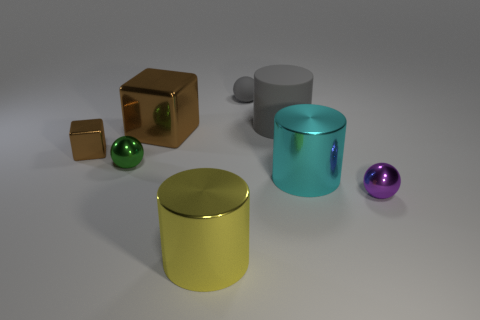What material is the tiny ball that is on the right side of the matte thing that is on the left side of the big gray matte object?
Give a very brief answer. Metal. How big is the ball that is on the left side of the small matte sphere?
Your answer should be compact. Small. There is a small matte thing; is it the same color as the big cylinder that is behind the big cyan cylinder?
Your answer should be very brief. Yes. Are there any other blocks of the same color as the small metallic block?
Ensure brevity in your answer.  Yes. Is the tiny cube made of the same material as the sphere to the left of the big yellow metal cylinder?
Make the answer very short. Yes. What number of small objects are blocks or green shiny balls?
Ensure brevity in your answer.  2. What material is the small sphere that is the same color as the large rubber object?
Give a very brief answer. Rubber. Are there fewer green shiny balls than large matte blocks?
Make the answer very short. No. Does the thing that is in front of the purple sphere have the same size as the metal cylinder right of the yellow shiny thing?
Your response must be concise. Yes. What number of gray objects are either big metal cubes or big metal cylinders?
Give a very brief answer. 0. 